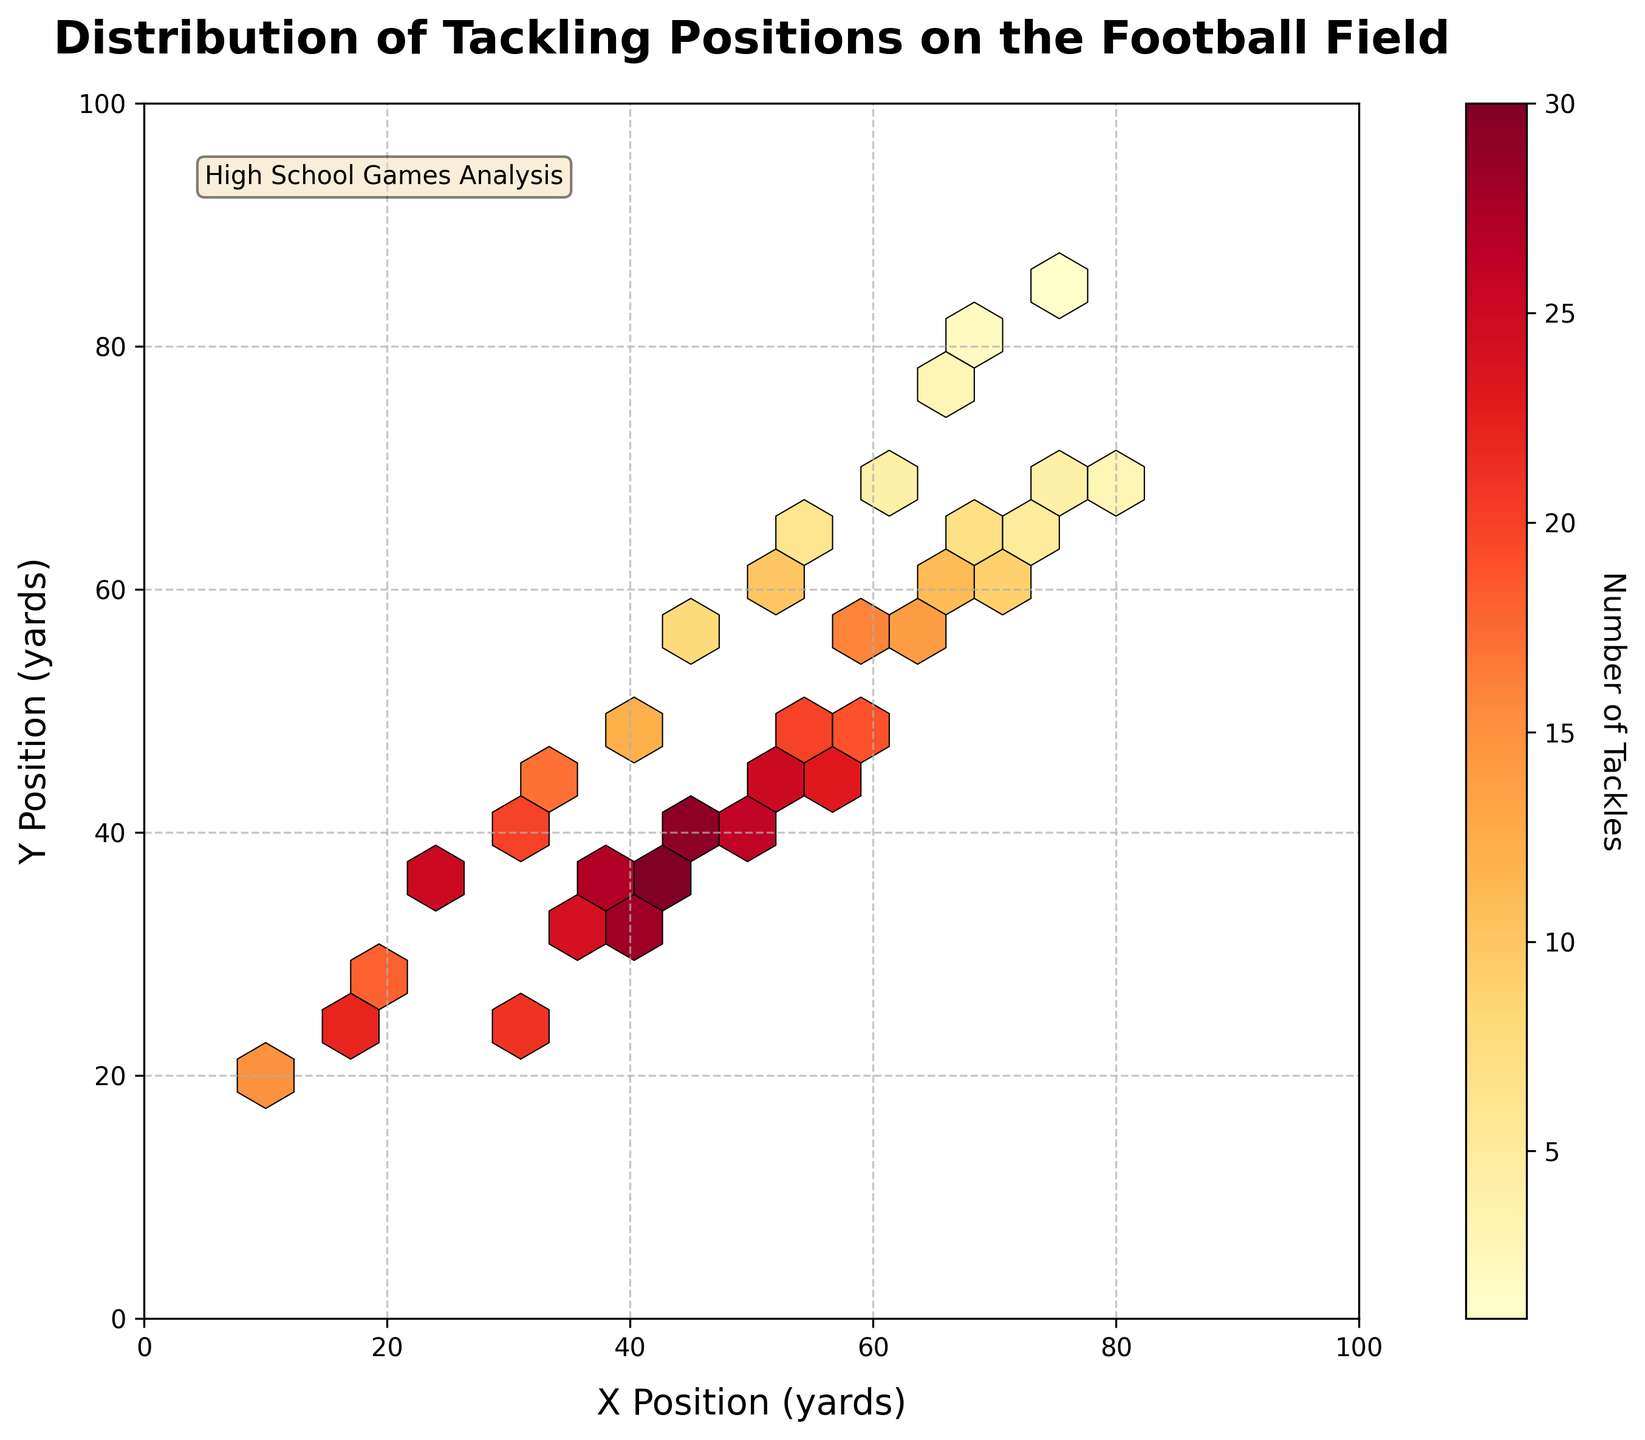what is the title of the figure? The title of the figure is located at the top of the plot and usually represents the content or focus of the plot. In this case, it should describe what is being visualized in terms of tackling positions.
Answer: Distribution of Tackling Positions on the Football Field What are the labels of the x and y axes? The x and y axis labels provide context for what the axes represent. Here they indicate positions in yards on the football field.
Answer: X Position (yards), Y Position (yards) What is the color representing in the plot? In a hexbin plot, color usually represents the intensity or count of data points within each hex bin. The color bar label helps us understand this representation.
Answer: Number of Tackles What are the range values shown on the color bar? To understand the distribution, we need to look at the values indicated on the color bar, which show the count range from lower to higher frequency.
Answer: 1 to 30 Which area has the highest concentration of tackles? To find this out, one should look for the hexagon with the darkest color on the plot indicating the highest number of tackles.
Answer: Near X=45, Y=35 How many unique tackling spots have a count greater than 20? To answer this, one needs to analyze which hexagons have colors corresponding to a count greater than 20. There can be multiple such spots.
Answer: 12 hexagons What is the average count of tackles for spots where X is between 30 and 50? To find this, sum up the counts for the hexagons in the X=30 to 50 range and divide by the number of such hexagons. (21+24+27+29+28+30+26+25)/8 = 23.75
Answer: 23.75 Compare the tackling spots at X=40, Y=30, and X=50, Y=40. Which one has more tackles? Check the counts for these specific coordinates and compare the values to determine which has more tackles.
Answer: X=45, Y=35 has more tackles Is the overall distribution of tackles more dispersed toward higher X or Y values? To answer this, observe the spread of colored hexagons. If more spread along X or Y indicates dispersion in that direction.
Answer: More towards higher values of Y What aspect ratio is used in the plot? The aspect ratio refers to the relationship between the width and height of the plot to maintain proportionality. Check the description or visual inspection.
Answer: Equal 